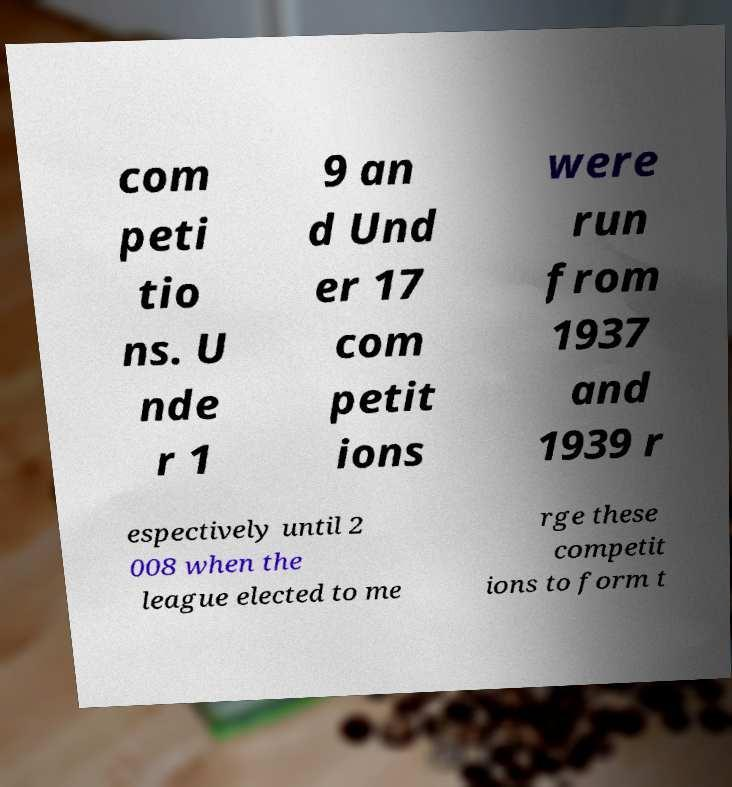There's text embedded in this image that I need extracted. Can you transcribe it verbatim? com peti tio ns. U nde r 1 9 an d Und er 17 com petit ions were run from 1937 and 1939 r espectively until 2 008 when the league elected to me rge these competit ions to form t 